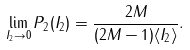<formula> <loc_0><loc_0><loc_500><loc_500>\lim _ { I _ { 2 } \rightarrow 0 } P _ { 2 } ( I _ { 2 } ) = \frac { 2 M } { ( 2 M - 1 ) \langle I _ { 2 } \rangle } .</formula> 